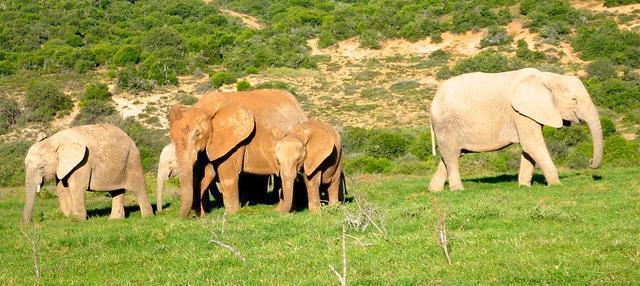What color is the elephant on the right?
Choose the correct response and explain in the format: 'Answer: answer
Rationale: rationale.'
Options: Brown, pink, gray, white. Answer: white.
Rationale: The color is white. What color is the skin of the dirty elephant in the middle?
Answer the question by selecting the correct answer among the 4 following choices and explain your choice with a short sentence. The answer should be formatted with the following format: `Answer: choice
Rationale: rationale.`
Options: Ivory, bronze, pink, gray. Answer: bronze.
Rationale: An elephant covered in mud appears orange compared to others around him. 